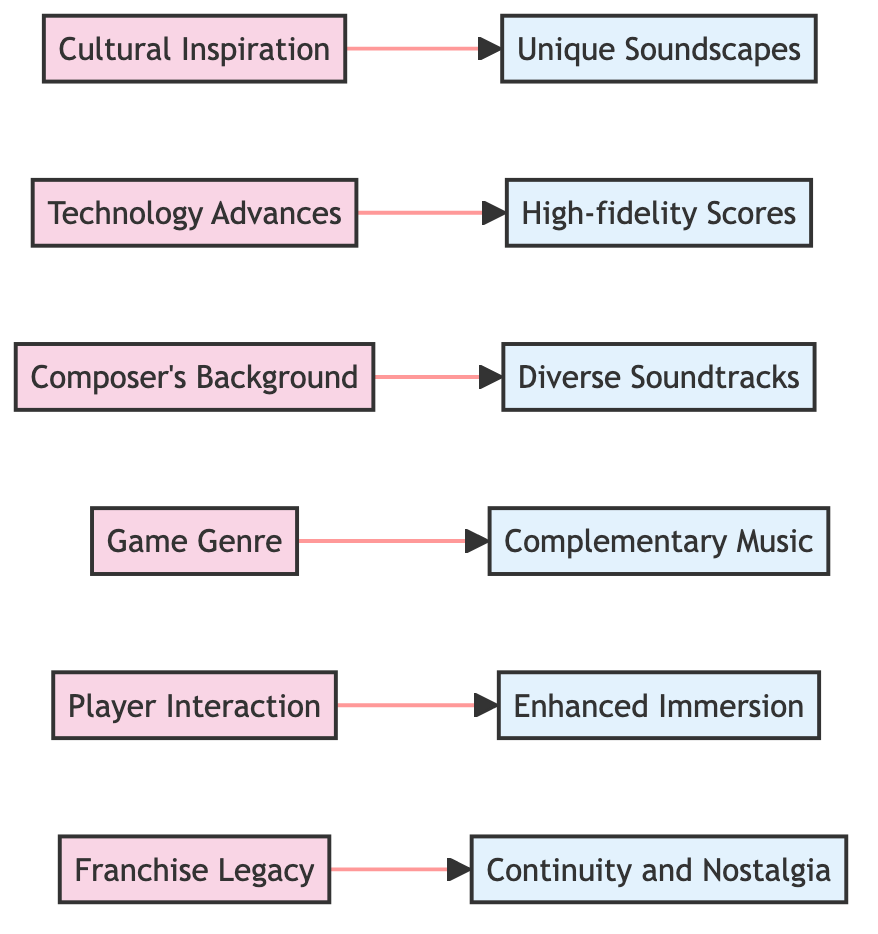What influence is associated with "High-fidelity Scores"? The "High-fidelity Scores" outcome is linked to the "Technology Advances" influence that utilizes improvements in music production.
Answer: Technology Advances Which example is related to the influence of "Cultural Inspiration"? The example related to "Cultural Inspiration" is "Japanese Folk Music in 'The Legend of Zelda: Ocarina of Time'".
Answer: Japanese Folk Music in 'The Legend of Zelda: Ocarina of Time' How many influences are there in the diagram? There are a total of six influences presented in the diagram.
Answer: 6 What outcome results from "Player Interaction"? "Player Interaction" leads to the outcome of "Enhanced Player Immersion through Real-time Music Variation".
Answer: Enhanced Player Immersion through Real-time Music Variation Which influence leads to "Diverse Soundtracks"? The influence that leads to "Diverse Soundtracks" is the "Composer's Background".
Answer: Composer's Background What is the relation between "Game Genre" and its outcome? "Game Genre" influences the music to "Complement the Thematic Elements" based on the specific game style.
Answer: Complementary Music Which two outcomes have a connection to the influences? "Unique Soundscapes That Enhance Immersion" is connected to "Cultural Inspiration" and "Continuity and Nostalgia for Long-time Fans" is connected to "Franchise Legacy".
Answer: Unique Soundscapes, Continuity and Nostalgia How are "Cultural Inspiration" and "Technology Advances" different? "Cultural Inspiration" draws from musical traditions, whereas "Technology Advances" leverages modern production tools. These influences yield distinct outcomes related to immersion and score quality.
Answer: Different focuses on culture vs. technology Which influence connects with the outcome of "Continuity and Nostalgia"? The outcome of "Continuity and Nostalgia for Long-time Fans" is connected to the influence of "Franchise Legacy".
Answer: Franchise Legacy 